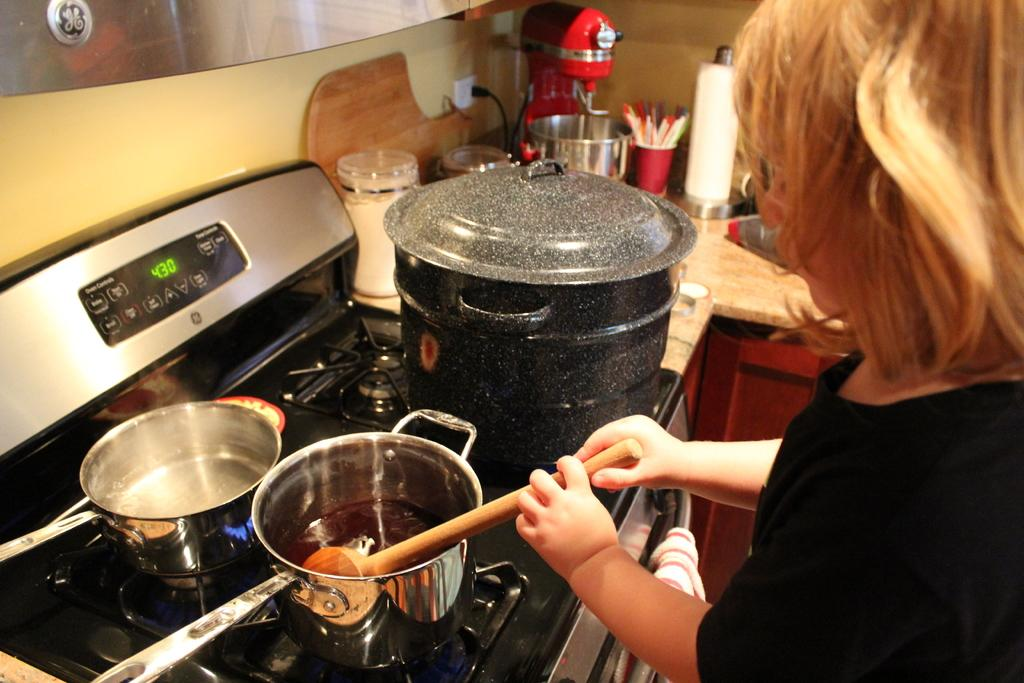<image>
Relay a brief, clear account of the picture shown. A woman is cooking sauce on the stove at 4:30 p.m. 